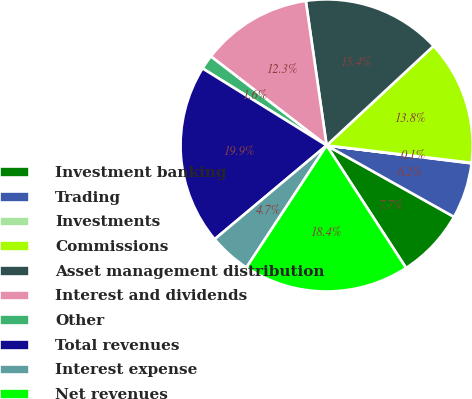<chart> <loc_0><loc_0><loc_500><loc_500><pie_chart><fcel>Investment banking<fcel>Trading<fcel>Investments<fcel>Commissions<fcel>Asset management distribution<fcel>Interest and dividends<fcel>Other<fcel>Total revenues<fcel>Interest expense<fcel>Net revenues<nl><fcel>7.71%<fcel>6.18%<fcel>0.06%<fcel>13.82%<fcel>15.35%<fcel>12.29%<fcel>1.59%<fcel>19.94%<fcel>4.65%<fcel>18.41%<nl></chart> 